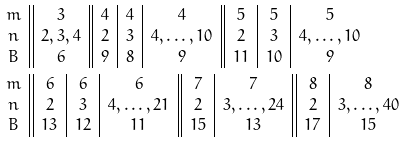<formula> <loc_0><loc_0><loc_500><loc_500>& \begin{array} { c | | c | | c | c | c | | c | c | c } m & 3 & 4 & 4 & 4 & 5 & 5 & 5 \\ n & 2 , 3 , 4 & 2 & 3 & 4 , \dots , 1 0 & 2 & 3 & 4 , \dots , 1 0 \\ B & 6 & 9 & 8 & 9 & 1 1 & 1 0 & 9 \end{array} \\ & \begin{array} { c | | c | c | c | | c | c | | c | c } m & 6 & 6 & 6 & 7 & 7 & 8 & 8 \\ n & 2 & 3 & 4 , \dots , 2 1 & 2 & 3 , \dots , 2 4 & 2 & 3 , \dots , 4 0 \\ B & 1 3 & 1 2 & 1 1 & 1 5 & 1 3 & 1 7 & 1 5 \end{array}</formula> 